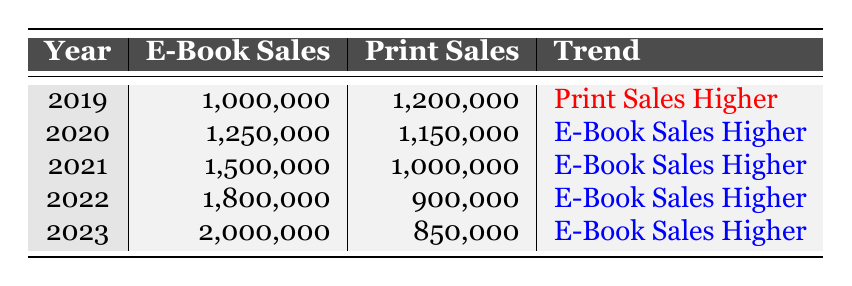What were the e-book sales in 2022? The e-book sales for 2022 are directly listed in the table under the "E-Book Sales" column for the year 2022, which shows 1,800,000.
Answer: 1,800,000 Which year had the highest print sales? By looking at the "Print Sales" column, the year with the highest print sales is 2019, which recorded 1,200,000.
Answer: 2019 What is the difference in e-book sales between 2020 and 2021? The e-book sales for 2020 are 1,250,000 and for 2021 are 1,500,000. The difference is 1,500,000 - 1,250,000 = 250,000.
Answer: 250,000 Did e-book sales ever decrease from one year to the next? By comparing the e-book sales across the years, it can be observed that they consistently increased since 2019; there were no decreases.
Answer: No What was the average print sales over the five years? To find the average, sum the print sales from each year (1,200,000 + 1,150,000 + 1,000,000 + 900,000 + 850,000 = 5,100,000) and divide by 5; therefore, the average is 5,100,000 / 5 = 1,020,000.
Answer: 1,020,000 In which year did e-book sales surpass the 1 million mark for the first time? Analyzing the table shows that e-book sales surpassed 1 million in 2020, as it's the first year with e-book sales of 1,250,000.
Answer: 2020 Was there a year when e-book sales were higher than print sales? From the data, starting from the year 2020, e-book sales were higher than print sales in all subsequent years, confirming that this statement is true post-2019.
Answer: Yes What was the trend in sales from 2019 to 2023? Observing the trends listed, print sales were higher in 2019, but since 2020, e-book sales have consistently been higher each year, indicating a significant shift favoring e-books.
Answer: E-Book Sales Higher 